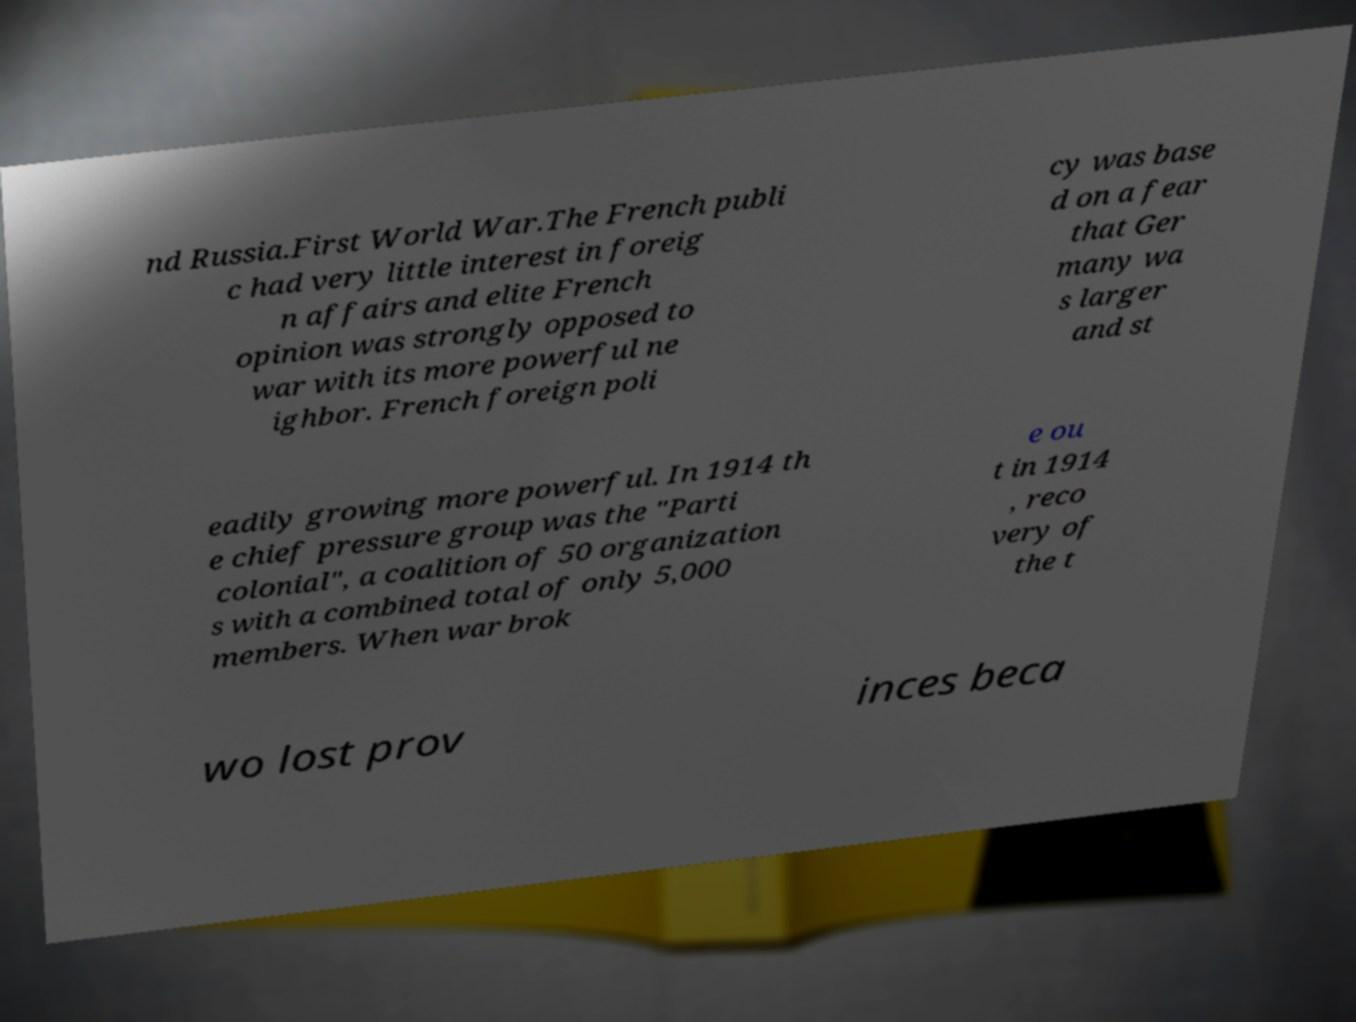Please identify and transcribe the text found in this image. nd Russia.First World War.The French publi c had very little interest in foreig n affairs and elite French opinion was strongly opposed to war with its more powerful ne ighbor. French foreign poli cy was base d on a fear that Ger many wa s larger and st eadily growing more powerful. In 1914 th e chief pressure group was the "Parti colonial", a coalition of 50 organization s with a combined total of only 5,000 members. When war brok e ou t in 1914 , reco very of the t wo lost prov inces beca 